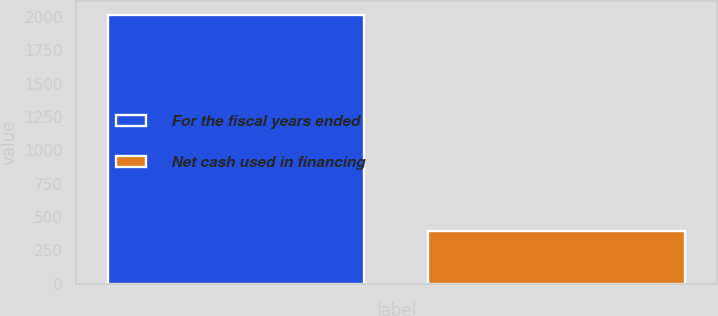Convert chart. <chart><loc_0><loc_0><loc_500><loc_500><bar_chart><fcel>For the fiscal years ended<fcel>Net cash used in financing<nl><fcel>2018<fcel>398<nl></chart> 